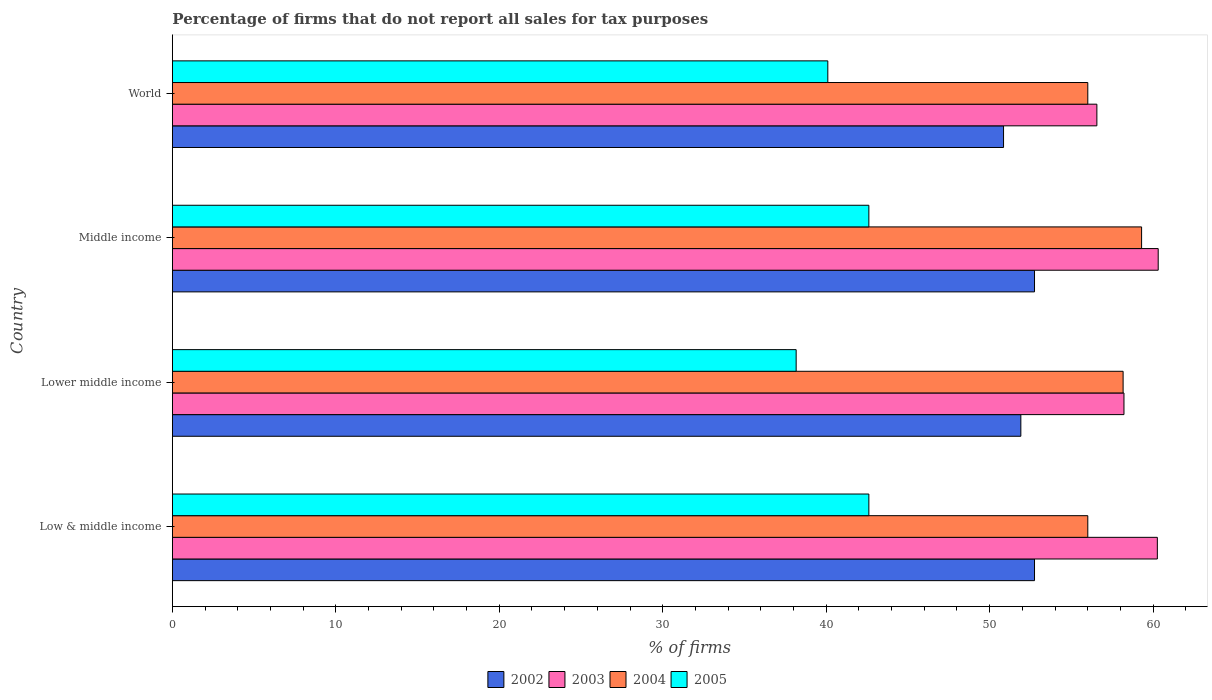How many bars are there on the 4th tick from the top?
Make the answer very short. 4. In how many cases, is the number of bars for a given country not equal to the number of legend labels?
Your response must be concise. 0. What is the percentage of firms that do not report all sales for tax purposes in 2004 in World?
Ensure brevity in your answer.  56.01. Across all countries, what is the maximum percentage of firms that do not report all sales for tax purposes in 2002?
Provide a short and direct response. 52.75. Across all countries, what is the minimum percentage of firms that do not report all sales for tax purposes in 2003?
Offer a terse response. 56.56. In which country was the percentage of firms that do not report all sales for tax purposes in 2002 minimum?
Provide a short and direct response. World. What is the total percentage of firms that do not report all sales for tax purposes in 2005 in the graph?
Make the answer very short. 163.48. What is the difference between the percentage of firms that do not report all sales for tax purposes in 2003 in Lower middle income and that in Middle income?
Your response must be concise. -2.09. What is the difference between the percentage of firms that do not report all sales for tax purposes in 2004 in World and the percentage of firms that do not report all sales for tax purposes in 2002 in Low & middle income?
Offer a very short reply. 3.26. What is the average percentage of firms that do not report all sales for tax purposes in 2003 per country?
Your answer should be compact. 58.84. What is the difference between the percentage of firms that do not report all sales for tax purposes in 2003 and percentage of firms that do not report all sales for tax purposes in 2005 in World?
Offer a very short reply. 16.46. What is the ratio of the percentage of firms that do not report all sales for tax purposes in 2005 in Low & middle income to that in World?
Make the answer very short. 1.06. What is the difference between the highest and the second highest percentage of firms that do not report all sales for tax purposes in 2004?
Offer a terse response. 1.13. What is the difference between the highest and the lowest percentage of firms that do not report all sales for tax purposes in 2004?
Provide a short and direct response. 3.29. In how many countries, is the percentage of firms that do not report all sales for tax purposes in 2003 greater than the average percentage of firms that do not report all sales for tax purposes in 2003 taken over all countries?
Make the answer very short. 2. Is the sum of the percentage of firms that do not report all sales for tax purposes in 2002 in Lower middle income and Middle income greater than the maximum percentage of firms that do not report all sales for tax purposes in 2005 across all countries?
Provide a short and direct response. Yes. Is it the case that in every country, the sum of the percentage of firms that do not report all sales for tax purposes in 2002 and percentage of firms that do not report all sales for tax purposes in 2004 is greater than the sum of percentage of firms that do not report all sales for tax purposes in 2003 and percentage of firms that do not report all sales for tax purposes in 2005?
Make the answer very short. Yes. What does the 2nd bar from the top in Low & middle income represents?
Make the answer very short. 2004. What does the 3rd bar from the bottom in Lower middle income represents?
Keep it short and to the point. 2004. What is the difference between two consecutive major ticks on the X-axis?
Give a very brief answer. 10. Does the graph contain grids?
Give a very brief answer. No. How many legend labels are there?
Your answer should be very brief. 4. How are the legend labels stacked?
Provide a short and direct response. Horizontal. What is the title of the graph?
Offer a very short reply. Percentage of firms that do not report all sales for tax purposes. Does "1960" appear as one of the legend labels in the graph?
Your answer should be very brief. No. What is the label or title of the X-axis?
Your answer should be very brief. % of firms. What is the % of firms of 2002 in Low & middle income?
Keep it short and to the point. 52.75. What is the % of firms of 2003 in Low & middle income?
Offer a very short reply. 60.26. What is the % of firms of 2004 in Low & middle income?
Make the answer very short. 56.01. What is the % of firms in 2005 in Low & middle income?
Your response must be concise. 42.61. What is the % of firms of 2002 in Lower middle income?
Your response must be concise. 51.91. What is the % of firms in 2003 in Lower middle income?
Offer a very short reply. 58.22. What is the % of firms in 2004 in Lower middle income?
Offer a very short reply. 58.16. What is the % of firms of 2005 in Lower middle income?
Offer a terse response. 38.16. What is the % of firms of 2002 in Middle income?
Provide a succinct answer. 52.75. What is the % of firms of 2003 in Middle income?
Your answer should be very brief. 60.31. What is the % of firms in 2004 in Middle income?
Your answer should be compact. 59.3. What is the % of firms of 2005 in Middle income?
Offer a very short reply. 42.61. What is the % of firms of 2002 in World?
Give a very brief answer. 50.85. What is the % of firms in 2003 in World?
Offer a terse response. 56.56. What is the % of firms in 2004 in World?
Your response must be concise. 56.01. What is the % of firms in 2005 in World?
Your answer should be very brief. 40.1. Across all countries, what is the maximum % of firms in 2002?
Give a very brief answer. 52.75. Across all countries, what is the maximum % of firms of 2003?
Keep it short and to the point. 60.31. Across all countries, what is the maximum % of firms of 2004?
Provide a succinct answer. 59.3. Across all countries, what is the maximum % of firms in 2005?
Offer a terse response. 42.61. Across all countries, what is the minimum % of firms of 2002?
Keep it short and to the point. 50.85. Across all countries, what is the minimum % of firms in 2003?
Your answer should be compact. 56.56. Across all countries, what is the minimum % of firms in 2004?
Offer a terse response. 56.01. Across all countries, what is the minimum % of firms in 2005?
Offer a terse response. 38.16. What is the total % of firms in 2002 in the graph?
Offer a terse response. 208.25. What is the total % of firms in 2003 in the graph?
Ensure brevity in your answer.  235.35. What is the total % of firms of 2004 in the graph?
Make the answer very short. 229.47. What is the total % of firms in 2005 in the graph?
Keep it short and to the point. 163.48. What is the difference between the % of firms of 2002 in Low & middle income and that in Lower middle income?
Provide a short and direct response. 0.84. What is the difference between the % of firms in 2003 in Low & middle income and that in Lower middle income?
Offer a terse response. 2.04. What is the difference between the % of firms in 2004 in Low & middle income and that in Lower middle income?
Keep it short and to the point. -2.16. What is the difference between the % of firms in 2005 in Low & middle income and that in Lower middle income?
Make the answer very short. 4.45. What is the difference between the % of firms in 2002 in Low & middle income and that in Middle income?
Offer a terse response. 0. What is the difference between the % of firms in 2003 in Low & middle income and that in Middle income?
Offer a very short reply. -0.05. What is the difference between the % of firms in 2004 in Low & middle income and that in Middle income?
Make the answer very short. -3.29. What is the difference between the % of firms in 2005 in Low & middle income and that in Middle income?
Offer a terse response. 0. What is the difference between the % of firms of 2002 in Low & middle income and that in World?
Your response must be concise. 1.89. What is the difference between the % of firms in 2003 in Low & middle income and that in World?
Your answer should be very brief. 3.7. What is the difference between the % of firms in 2005 in Low & middle income and that in World?
Make the answer very short. 2.51. What is the difference between the % of firms in 2002 in Lower middle income and that in Middle income?
Provide a short and direct response. -0.84. What is the difference between the % of firms in 2003 in Lower middle income and that in Middle income?
Offer a terse response. -2.09. What is the difference between the % of firms of 2004 in Lower middle income and that in Middle income?
Ensure brevity in your answer.  -1.13. What is the difference between the % of firms of 2005 in Lower middle income and that in Middle income?
Ensure brevity in your answer.  -4.45. What is the difference between the % of firms of 2002 in Lower middle income and that in World?
Your answer should be compact. 1.06. What is the difference between the % of firms of 2003 in Lower middle income and that in World?
Make the answer very short. 1.66. What is the difference between the % of firms in 2004 in Lower middle income and that in World?
Make the answer very short. 2.16. What is the difference between the % of firms of 2005 in Lower middle income and that in World?
Offer a terse response. -1.94. What is the difference between the % of firms in 2002 in Middle income and that in World?
Provide a short and direct response. 1.89. What is the difference between the % of firms in 2003 in Middle income and that in World?
Offer a very short reply. 3.75. What is the difference between the % of firms in 2004 in Middle income and that in World?
Offer a very short reply. 3.29. What is the difference between the % of firms of 2005 in Middle income and that in World?
Ensure brevity in your answer.  2.51. What is the difference between the % of firms of 2002 in Low & middle income and the % of firms of 2003 in Lower middle income?
Your answer should be very brief. -5.47. What is the difference between the % of firms in 2002 in Low & middle income and the % of firms in 2004 in Lower middle income?
Keep it short and to the point. -5.42. What is the difference between the % of firms of 2002 in Low & middle income and the % of firms of 2005 in Lower middle income?
Provide a short and direct response. 14.58. What is the difference between the % of firms in 2003 in Low & middle income and the % of firms in 2004 in Lower middle income?
Your response must be concise. 2.1. What is the difference between the % of firms in 2003 in Low & middle income and the % of firms in 2005 in Lower middle income?
Keep it short and to the point. 22.1. What is the difference between the % of firms of 2004 in Low & middle income and the % of firms of 2005 in Lower middle income?
Ensure brevity in your answer.  17.84. What is the difference between the % of firms of 2002 in Low & middle income and the % of firms of 2003 in Middle income?
Ensure brevity in your answer.  -7.57. What is the difference between the % of firms of 2002 in Low & middle income and the % of firms of 2004 in Middle income?
Offer a terse response. -6.55. What is the difference between the % of firms of 2002 in Low & middle income and the % of firms of 2005 in Middle income?
Your response must be concise. 10.13. What is the difference between the % of firms of 2003 in Low & middle income and the % of firms of 2004 in Middle income?
Make the answer very short. 0.96. What is the difference between the % of firms in 2003 in Low & middle income and the % of firms in 2005 in Middle income?
Keep it short and to the point. 17.65. What is the difference between the % of firms of 2004 in Low & middle income and the % of firms of 2005 in Middle income?
Make the answer very short. 13.39. What is the difference between the % of firms in 2002 in Low & middle income and the % of firms in 2003 in World?
Ensure brevity in your answer.  -3.81. What is the difference between the % of firms of 2002 in Low & middle income and the % of firms of 2004 in World?
Give a very brief answer. -3.26. What is the difference between the % of firms of 2002 in Low & middle income and the % of firms of 2005 in World?
Provide a short and direct response. 12.65. What is the difference between the % of firms of 2003 in Low & middle income and the % of firms of 2004 in World?
Provide a succinct answer. 4.25. What is the difference between the % of firms of 2003 in Low & middle income and the % of firms of 2005 in World?
Provide a succinct answer. 20.16. What is the difference between the % of firms of 2004 in Low & middle income and the % of firms of 2005 in World?
Make the answer very short. 15.91. What is the difference between the % of firms in 2002 in Lower middle income and the % of firms in 2003 in Middle income?
Your response must be concise. -8.4. What is the difference between the % of firms in 2002 in Lower middle income and the % of firms in 2004 in Middle income?
Keep it short and to the point. -7.39. What is the difference between the % of firms in 2002 in Lower middle income and the % of firms in 2005 in Middle income?
Offer a terse response. 9.3. What is the difference between the % of firms in 2003 in Lower middle income and the % of firms in 2004 in Middle income?
Provide a succinct answer. -1.08. What is the difference between the % of firms of 2003 in Lower middle income and the % of firms of 2005 in Middle income?
Keep it short and to the point. 15.61. What is the difference between the % of firms of 2004 in Lower middle income and the % of firms of 2005 in Middle income?
Provide a succinct answer. 15.55. What is the difference between the % of firms of 2002 in Lower middle income and the % of firms of 2003 in World?
Provide a succinct answer. -4.65. What is the difference between the % of firms of 2002 in Lower middle income and the % of firms of 2004 in World?
Make the answer very short. -4.1. What is the difference between the % of firms in 2002 in Lower middle income and the % of firms in 2005 in World?
Your response must be concise. 11.81. What is the difference between the % of firms of 2003 in Lower middle income and the % of firms of 2004 in World?
Offer a very short reply. 2.21. What is the difference between the % of firms of 2003 in Lower middle income and the % of firms of 2005 in World?
Make the answer very short. 18.12. What is the difference between the % of firms in 2004 in Lower middle income and the % of firms in 2005 in World?
Offer a very short reply. 18.07. What is the difference between the % of firms in 2002 in Middle income and the % of firms in 2003 in World?
Give a very brief answer. -3.81. What is the difference between the % of firms in 2002 in Middle income and the % of firms in 2004 in World?
Give a very brief answer. -3.26. What is the difference between the % of firms of 2002 in Middle income and the % of firms of 2005 in World?
Your response must be concise. 12.65. What is the difference between the % of firms in 2003 in Middle income and the % of firms in 2004 in World?
Offer a terse response. 4.31. What is the difference between the % of firms of 2003 in Middle income and the % of firms of 2005 in World?
Your answer should be very brief. 20.21. What is the difference between the % of firms of 2004 in Middle income and the % of firms of 2005 in World?
Give a very brief answer. 19.2. What is the average % of firms in 2002 per country?
Make the answer very short. 52.06. What is the average % of firms in 2003 per country?
Ensure brevity in your answer.  58.84. What is the average % of firms of 2004 per country?
Make the answer very short. 57.37. What is the average % of firms of 2005 per country?
Offer a terse response. 40.87. What is the difference between the % of firms in 2002 and % of firms in 2003 in Low & middle income?
Give a very brief answer. -7.51. What is the difference between the % of firms of 2002 and % of firms of 2004 in Low & middle income?
Give a very brief answer. -3.26. What is the difference between the % of firms of 2002 and % of firms of 2005 in Low & middle income?
Provide a short and direct response. 10.13. What is the difference between the % of firms in 2003 and % of firms in 2004 in Low & middle income?
Give a very brief answer. 4.25. What is the difference between the % of firms of 2003 and % of firms of 2005 in Low & middle income?
Your response must be concise. 17.65. What is the difference between the % of firms in 2004 and % of firms in 2005 in Low & middle income?
Offer a terse response. 13.39. What is the difference between the % of firms of 2002 and % of firms of 2003 in Lower middle income?
Provide a succinct answer. -6.31. What is the difference between the % of firms in 2002 and % of firms in 2004 in Lower middle income?
Give a very brief answer. -6.26. What is the difference between the % of firms of 2002 and % of firms of 2005 in Lower middle income?
Provide a succinct answer. 13.75. What is the difference between the % of firms in 2003 and % of firms in 2004 in Lower middle income?
Your answer should be very brief. 0.05. What is the difference between the % of firms of 2003 and % of firms of 2005 in Lower middle income?
Offer a very short reply. 20.06. What is the difference between the % of firms of 2004 and % of firms of 2005 in Lower middle income?
Provide a succinct answer. 20. What is the difference between the % of firms in 2002 and % of firms in 2003 in Middle income?
Your answer should be very brief. -7.57. What is the difference between the % of firms of 2002 and % of firms of 2004 in Middle income?
Offer a terse response. -6.55. What is the difference between the % of firms of 2002 and % of firms of 2005 in Middle income?
Offer a very short reply. 10.13. What is the difference between the % of firms of 2003 and % of firms of 2004 in Middle income?
Your answer should be compact. 1.02. What is the difference between the % of firms of 2003 and % of firms of 2005 in Middle income?
Offer a terse response. 17.7. What is the difference between the % of firms of 2004 and % of firms of 2005 in Middle income?
Offer a terse response. 16.69. What is the difference between the % of firms of 2002 and % of firms of 2003 in World?
Give a very brief answer. -5.71. What is the difference between the % of firms of 2002 and % of firms of 2004 in World?
Offer a terse response. -5.15. What is the difference between the % of firms in 2002 and % of firms in 2005 in World?
Provide a short and direct response. 10.75. What is the difference between the % of firms in 2003 and % of firms in 2004 in World?
Offer a very short reply. 0.56. What is the difference between the % of firms of 2003 and % of firms of 2005 in World?
Make the answer very short. 16.46. What is the difference between the % of firms of 2004 and % of firms of 2005 in World?
Offer a terse response. 15.91. What is the ratio of the % of firms in 2002 in Low & middle income to that in Lower middle income?
Keep it short and to the point. 1.02. What is the ratio of the % of firms in 2003 in Low & middle income to that in Lower middle income?
Ensure brevity in your answer.  1.04. What is the ratio of the % of firms of 2004 in Low & middle income to that in Lower middle income?
Make the answer very short. 0.96. What is the ratio of the % of firms in 2005 in Low & middle income to that in Lower middle income?
Make the answer very short. 1.12. What is the ratio of the % of firms in 2004 in Low & middle income to that in Middle income?
Give a very brief answer. 0.94. What is the ratio of the % of firms of 2002 in Low & middle income to that in World?
Ensure brevity in your answer.  1.04. What is the ratio of the % of firms of 2003 in Low & middle income to that in World?
Make the answer very short. 1.07. What is the ratio of the % of firms of 2005 in Low & middle income to that in World?
Provide a succinct answer. 1.06. What is the ratio of the % of firms in 2002 in Lower middle income to that in Middle income?
Your response must be concise. 0.98. What is the ratio of the % of firms in 2003 in Lower middle income to that in Middle income?
Provide a succinct answer. 0.97. What is the ratio of the % of firms in 2004 in Lower middle income to that in Middle income?
Keep it short and to the point. 0.98. What is the ratio of the % of firms in 2005 in Lower middle income to that in Middle income?
Give a very brief answer. 0.9. What is the ratio of the % of firms of 2002 in Lower middle income to that in World?
Your answer should be very brief. 1.02. What is the ratio of the % of firms in 2003 in Lower middle income to that in World?
Give a very brief answer. 1.03. What is the ratio of the % of firms of 2004 in Lower middle income to that in World?
Make the answer very short. 1.04. What is the ratio of the % of firms of 2005 in Lower middle income to that in World?
Provide a succinct answer. 0.95. What is the ratio of the % of firms in 2002 in Middle income to that in World?
Provide a succinct answer. 1.04. What is the ratio of the % of firms in 2003 in Middle income to that in World?
Your response must be concise. 1.07. What is the ratio of the % of firms in 2004 in Middle income to that in World?
Ensure brevity in your answer.  1.06. What is the ratio of the % of firms of 2005 in Middle income to that in World?
Make the answer very short. 1.06. What is the difference between the highest and the second highest % of firms of 2003?
Provide a short and direct response. 0.05. What is the difference between the highest and the second highest % of firms of 2004?
Provide a succinct answer. 1.13. What is the difference between the highest and the second highest % of firms of 2005?
Ensure brevity in your answer.  0. What is the difference between the highest and the lowest % of firms of 2002?
Provide a succinct answer. 1.89. What is the difference between the highest and the lowest % of firms in 2003?
Offer a terse response. 3.75. What is the difference between the highest and the lowest % of firms of 2004?
Make the answer very short. 3.29. What is the difference between the highest and the lowest % of firms in 2005?
Your answer should be compact. 4.45. 